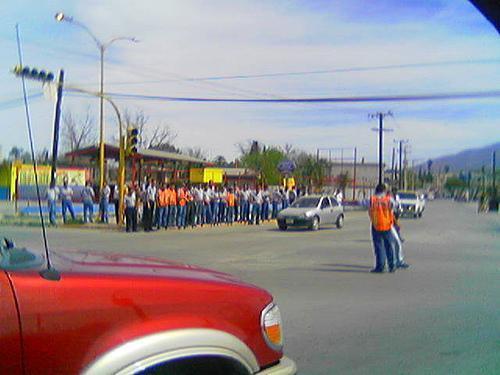What are these people doing here?
Select the correct answer and articulate reasoning with the following format: 'Answer: answer
Rationale: rationale.'
Options: Hired, help riders, awaiting ride, invited yesterday. Answer: awaiting ride.
Rationale: The people want a ride. 